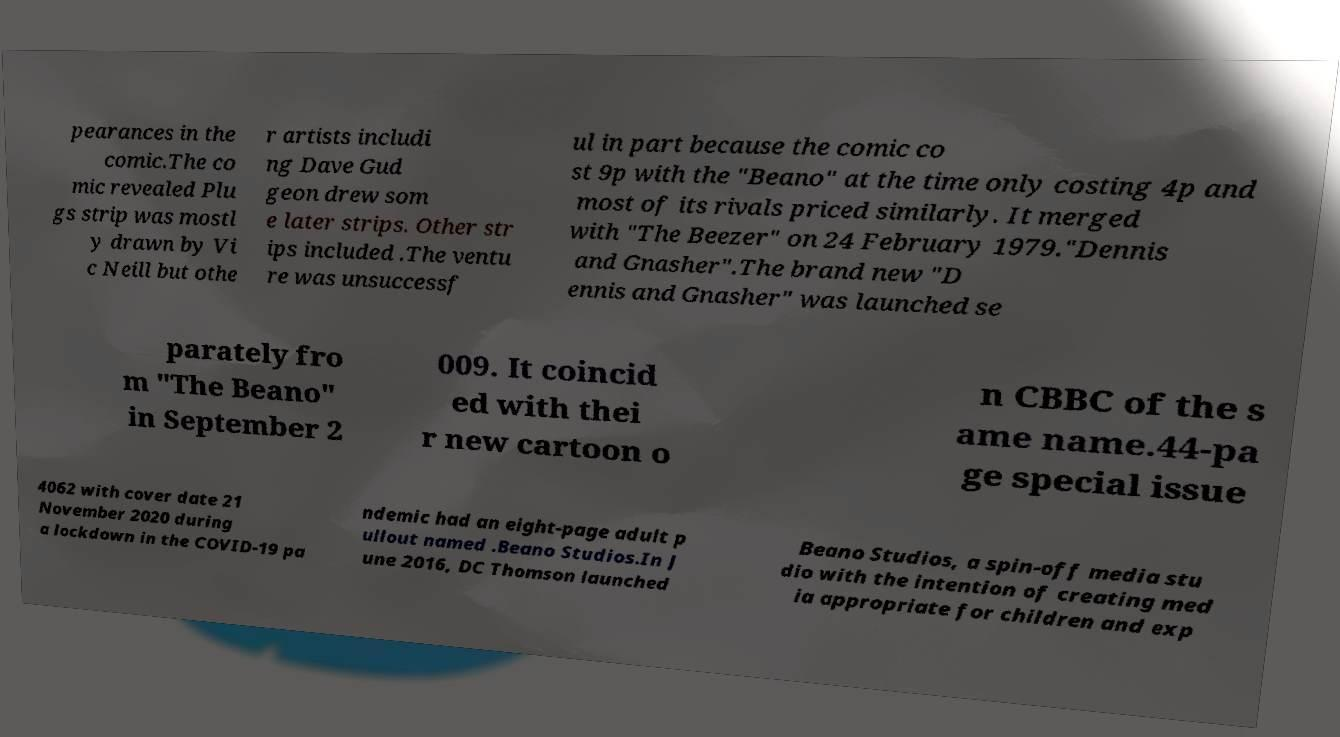Could you assist in decoding the text presented in this image and type it out clearly? pearances in the comic.The co mic revealed Plu gs strip was mostl y drawn by Vi c Neill but othe r artists includi ng Dave Gud geon drew som e later strips. Other str ips included .The ventu re was unsuccessf ul in part because the comic co st 9p with the "Beano" at the time only costing 4p and most of its rivals priced similarly. It merged with "The Beezer" on 24 February 1979."Dennis and Gnasher".The brand new "D ennis and Gnasher" was launched se parately fro m "The Beano" in September 2 009. It coincid ed with thei r new cartoon o n CBBC of the s ame name.44-pa ge special issue 4062 with cover date 21 November 2020 during a lockdown in the COVID-19 pa ndemic had an eight-page adult p ullout named .Beano Studios.In J une 2016, DC Thomson launched Beano Studios, a spin-off media stu dio with the intention of creating med ia appropriate for children and exp 